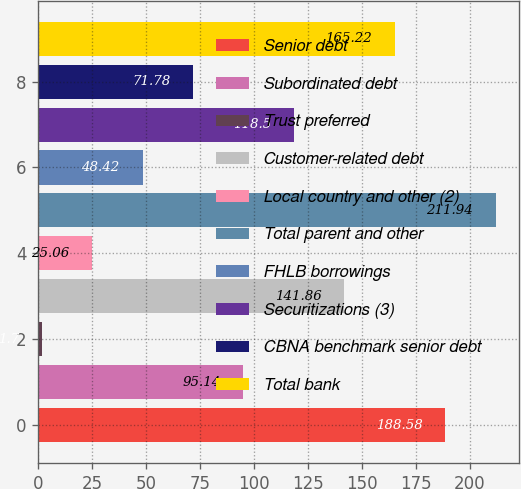Convert chart to OTSL. <chart><loc_0><loc_0><loc_500><loc_500><bar_chart><fcel>Senior debt<fcel>Subordinated debt<fcel>Trust preferred<fcel>Customer-related debt<fcel>Local country and other (2)<fcel>Total parent and other<fcel>FHLB borrowings<fcel>Securitizations (3)<fcel>CBNA benchmark senior debt<fcel>Total bank<nl><fcel>188.58<fcel>95.14<fcel>1.7<fcel>141.86<fcel>25.06<fcel>211.94<fcel>48.42<fcel>118.5<fcel>71.78<fcel>165.22<nl></chart> 